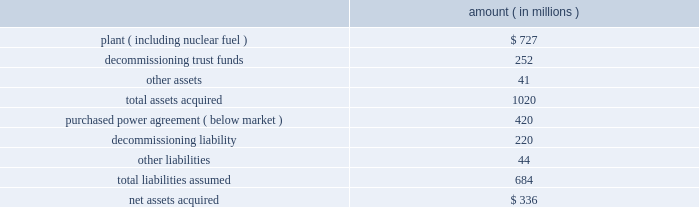Entergy corporation and subsidiaries notes to financial statements ouachita in september 2008 , entergy arkansas purchased the ouachita plant , a 789 mw three-train gas-fired combined cycle generating turbine ( ccgt ) electric power plant located 20 miles south of the arkansas state line near sterlington , louisiana , for approximately $ 210 million from a subsidiary of cogentrix energy , inc .
Entergy arkansas received the plant , materials and supplies , and related real estate in the transaction .
The ferc and the apsc approved the acquisition .
The apsc also approved the recovery of the acquisition and ownership costs through a rate rider and the planned sale of one-third of the capacity and energy to entergy gulf states louisiana .
The lpsc also approved the purchase of one-third of the capacity and energy by entergy gulf states louisiana , subject to certain conditions , including a study to determine the costs and benefits of entergy gulf states louisiana exercising an option to purchase one-third of the plant ( unit 3 ) from entergy arkansas .
Entergy gulf states louisiana is scheduled to report the results of that study by march 30 , 2009 .
Palisades in april 2007 , entergy's non-utility nuclear business purchased the 798 mw palisades nuclear energy plant located near south haven , michigan from consumers energy company for a net cash payment of $ 336 million .
Entergy received the plant , nuclear fuel , inventories , and other assets .
The liability to decommission the plant , as well as related decommissioning trust funds , was also transferred to entergy's non-utility nuclear business .
Entergy's non-utility nuclear business executed a unit-contingent , 15-year purchased power agreement ( ppa ) with consumers energy for 100% ( 100 % ) of the plant's output , excluding any future uprates .
Prices under the ppa range from $ 43.50/mwh in 2007 to $ 61.50/mwh in 2022 , and the average price under the ppa is $ 51/mwh .
In the first quarter 2007 , the nrc renewed palisades' operating license until 2031 .
As part of the transaction , entergy's non- utility nuclear business assumed responsibility for spent fuel at the decommissioned big rock point nuclear plant , which is located near charlevoix , michigan .
Palisades' financial results since april 2007 are included in entergy's non-utility nuclear business segment .
The table summarizes the assets acquired and liabilities assumed at the date of acquisition .
Amount ( in millions ) .
Subsequent to the closing , entergy received approximately $ 6 million from consumers energy company as part of the post-closing adjustment defined in the asset sale agreement .
The post-closing adjustment amount resulted in an approximately $ 6 million reduction in plant and a corresponding reduction in other liabilities .
For the ppa , which was at below-market prices at the time of the acquisition , non-utility nuclear will amortize a liability to revenue over the life of the agreement .
The amount that will be amortized each period is based upon the difference between the present value calculated at the date of acquisition of each year's difference between revenue under the agreement and revenue based on estimated market prices .
Amounts amortized to revenue were $ 76 .
What is the debt to asset ratio? 
Rationale: debt to asset ratio = total liabilities/total assets
Computations: (684 / 1020)
Answer: 0.67059. 